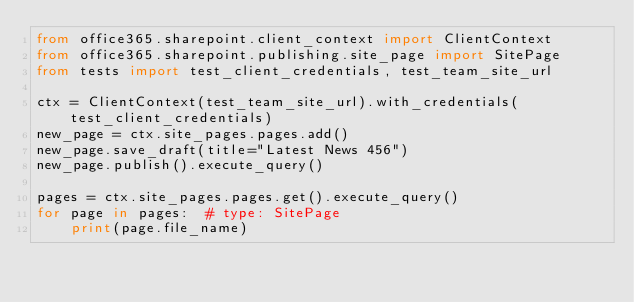Convert code to text. <code><loc_0><loc_0><loc_500><loc_500><_Python_>from office365.sharepoint.client_context import ClientContext
from office365.sharepoint.publishing.site_page import SitePage
from tests import test_client_credentials, test_team_site_url

ctx = ClientContext(test_team_site_url).with_credentials(test_client_credentials)
new_page = ctx.site_pages.pages.add()
new_page.save_draft(title="Latest News 456")
new_page.publish().execute_query()

pages = ctx.site_pages.pages.get().execute_query()
for page in pages:  # type: SitePage
    print(page.file_name)
</code> 